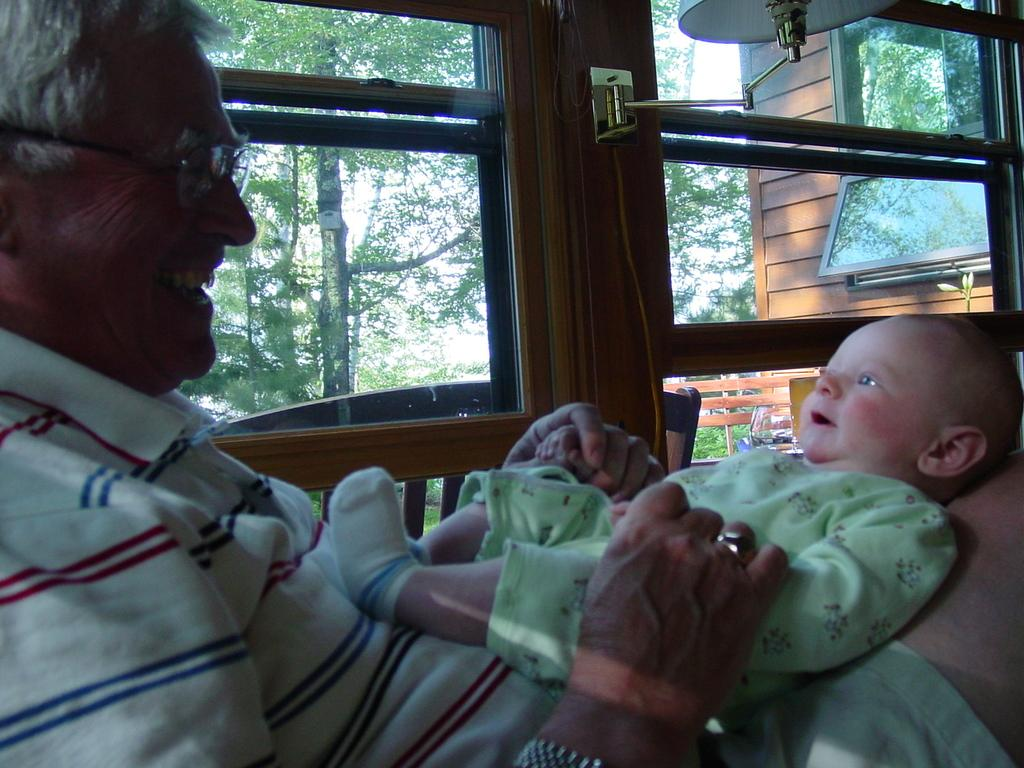Who is the main subject in the image? There is a man in the image. What is the man wearing? The man is wearing glasses (specs). What is the man doing in the image? The man is holding a baby on his lap. What can be seen in the background of the image? There are windows visible in the background, and trees can be seen through the windows. What type of lighting is present in the image? There is a lamp on the wall in the image. What type of suggestion does the governor make in the image? There is no governor present in the image, and therefore no suggestion can be made. Is there a cave visible in the image? There is no cave present in the image. 